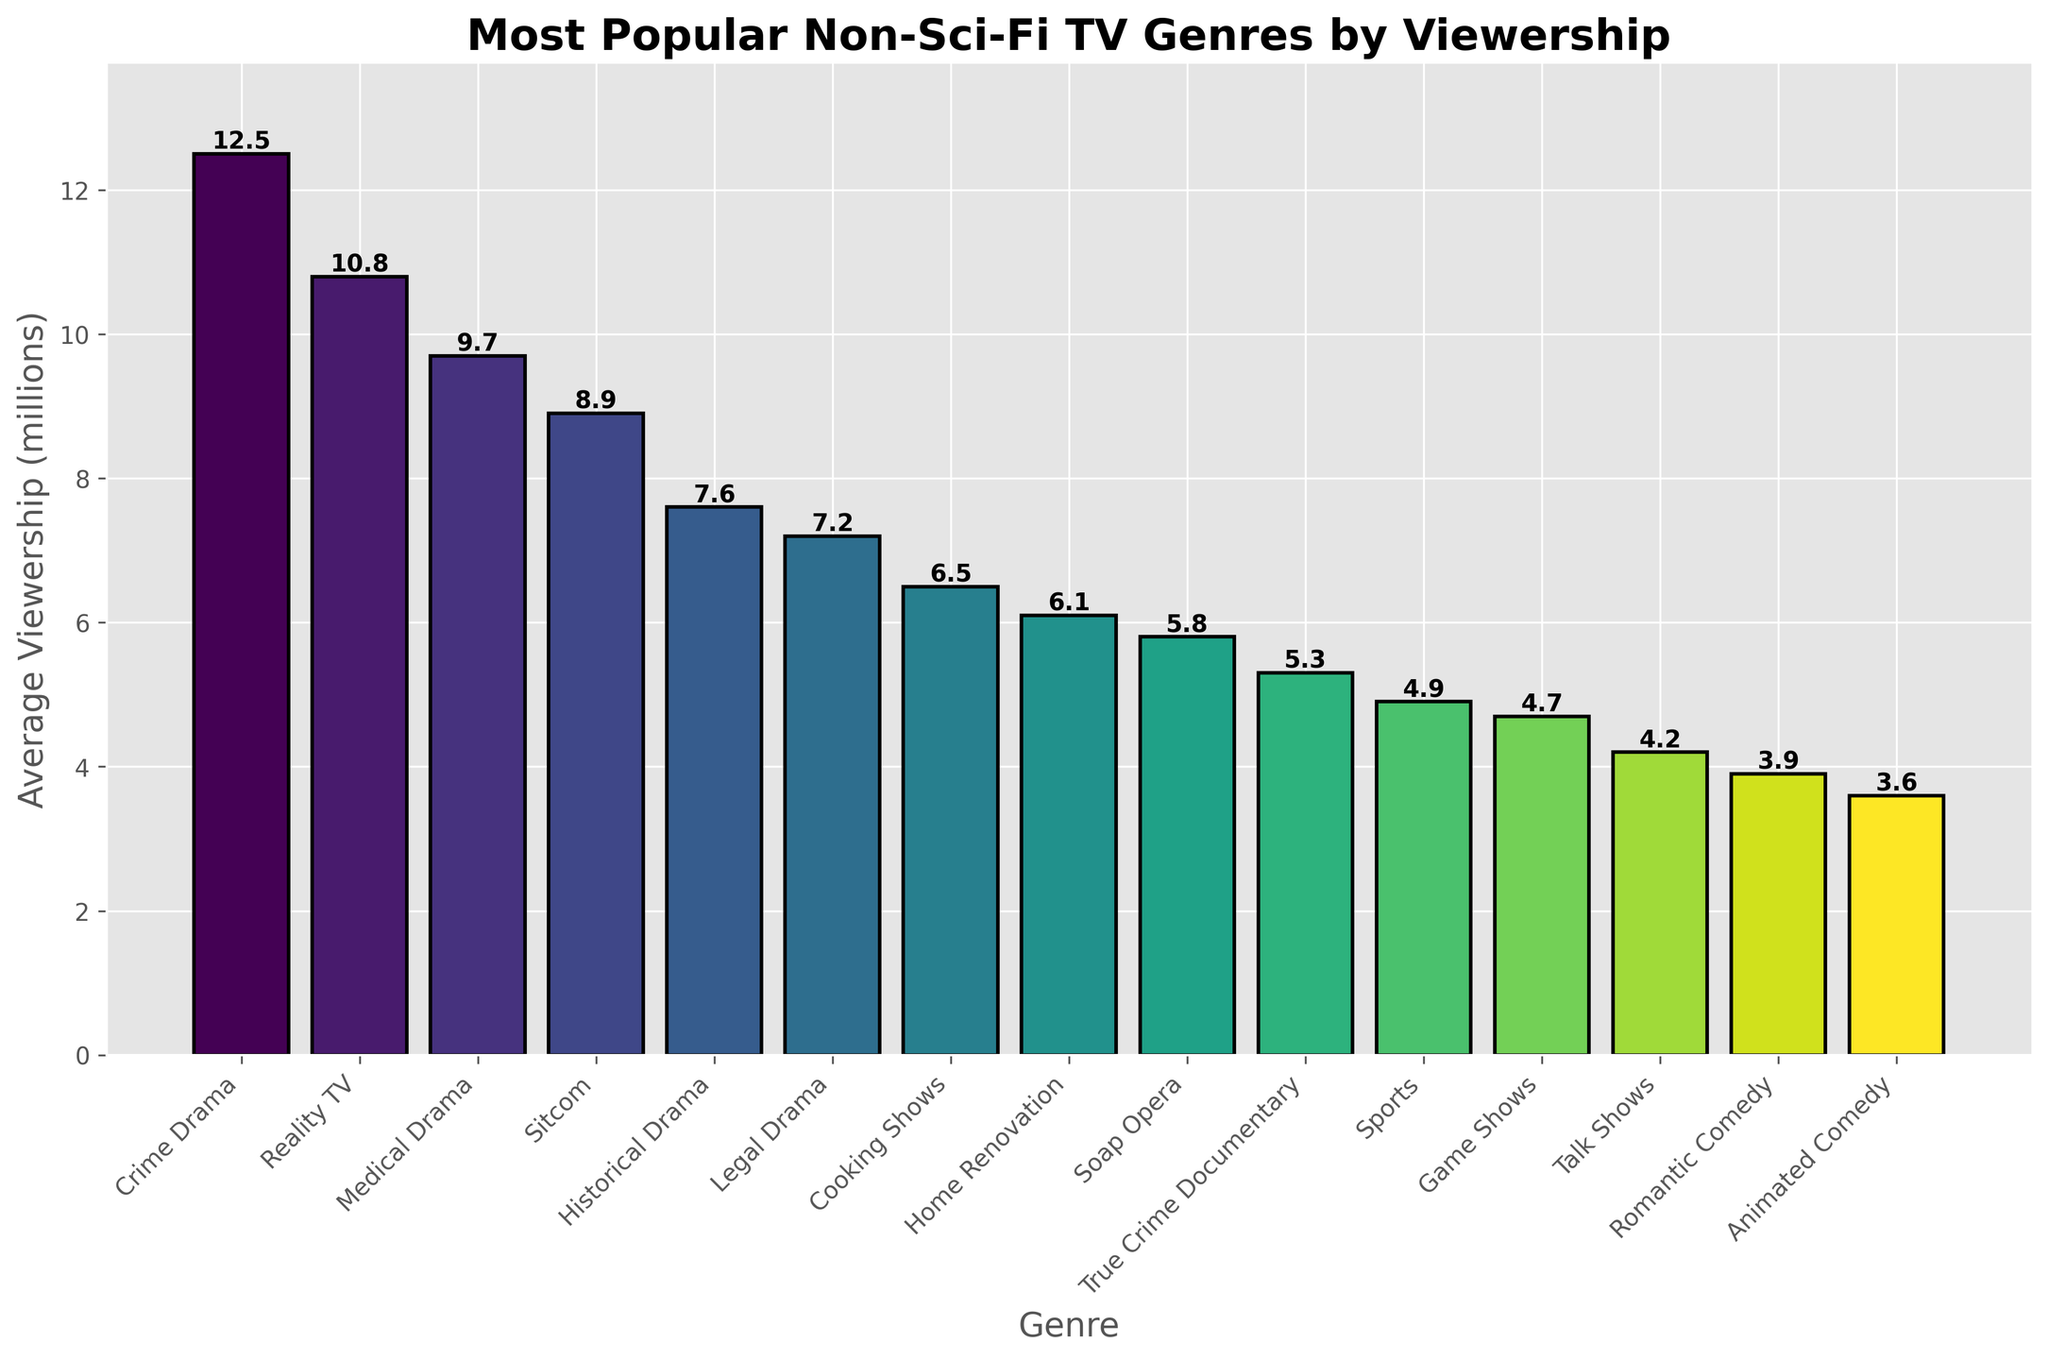Which TV genre has the highest average viewership? The bar chart shows the average viewership numbers for different TV genres. The highest bar represents the genre with the highest average viewership.
Answer: Crime Drama How much more average viewership does Crime Drama have compared to Sitcom? Crime Drama has an average viewership of 12.5 million, and Sitcom has 8.9 million. Subtract the viewership of Sitcom from Crime Drama: 12.5 - 8.9.
Answer: 3.6 million What is the combined viewership of Medical Drama and True Crime Documentary? Medical Drama has an average viewership of 9.7 million, and True Crime Documentary has 5.3 million. Add these values together: 9.7 + 5.3.
Answer: 15 million Rank the top three TV genres by average viewership. Refer to the heights of the bars and note the top three genres with the highest viewership numbers: Crime Drama (12.5 million), Reality TV (10.8 million), and Medical Drama (9.7 million).
Answer: Crime Drama, Reality TV, Medical Drama Which has fewer viewers, Home Renovation or Game Shows, and by how much? Home Renovation has 6.1 million viewers, and Game Shows have 4.7 million viewers. Subtract the viewership of Game Shows from Home Renovation: 6.1 - 4.7.
Answer: Game Shows by 1.4 million What is the average viewership of Reality TV shows when compared to the median viewership of all genres listed? First, list the viewership numbers and find the median. The sorted viewership numbers are [3.6, 3.9, 4.2, 4.7, 4.9, 5.3, 5.8, 6.1, 6.5, 7.2, 7.6, 8.9, 9.7, 10.8, 12.5]. The median is 6.5 million. Compare this to Reality TV's viewership of 10.8 million.
Answer: Reality TV is higher by 4.3 million Identify the genre with the lowest average viewership and state its value. Look for the shortest bar in the bar chart to find the genre with the lowest average viewership.
Answer: Animated Comedy with 3.6 million Is the average viewership of Cooking Shows closer to the viewership of Home Renovation or Soap Opera? Cooking Shows have 6.5 million viewers. Home Renovation has 6.1 million, and Soap Opera has 5.8 million. Find the differences:
Answer: Home Renovation (0.4 million difference) Which genre has approximately the same viewership as Sports? Find bars with heights close to the Sports bar, which has 4.9 million viewers.
Answer: Game Shows with 4.7 million What is the total viewership for all genres combined? Add the viewership numbers for all genres: 12.5 + 10.8 + 9.7 + 8.9 + 7.6 + 7.2 + 6.5 + 6.1 + 5.8 + 5.3 + 4.9 + 4.7 + 4.2 + 3.9 + 3.6.
Answer: 101.7 million 